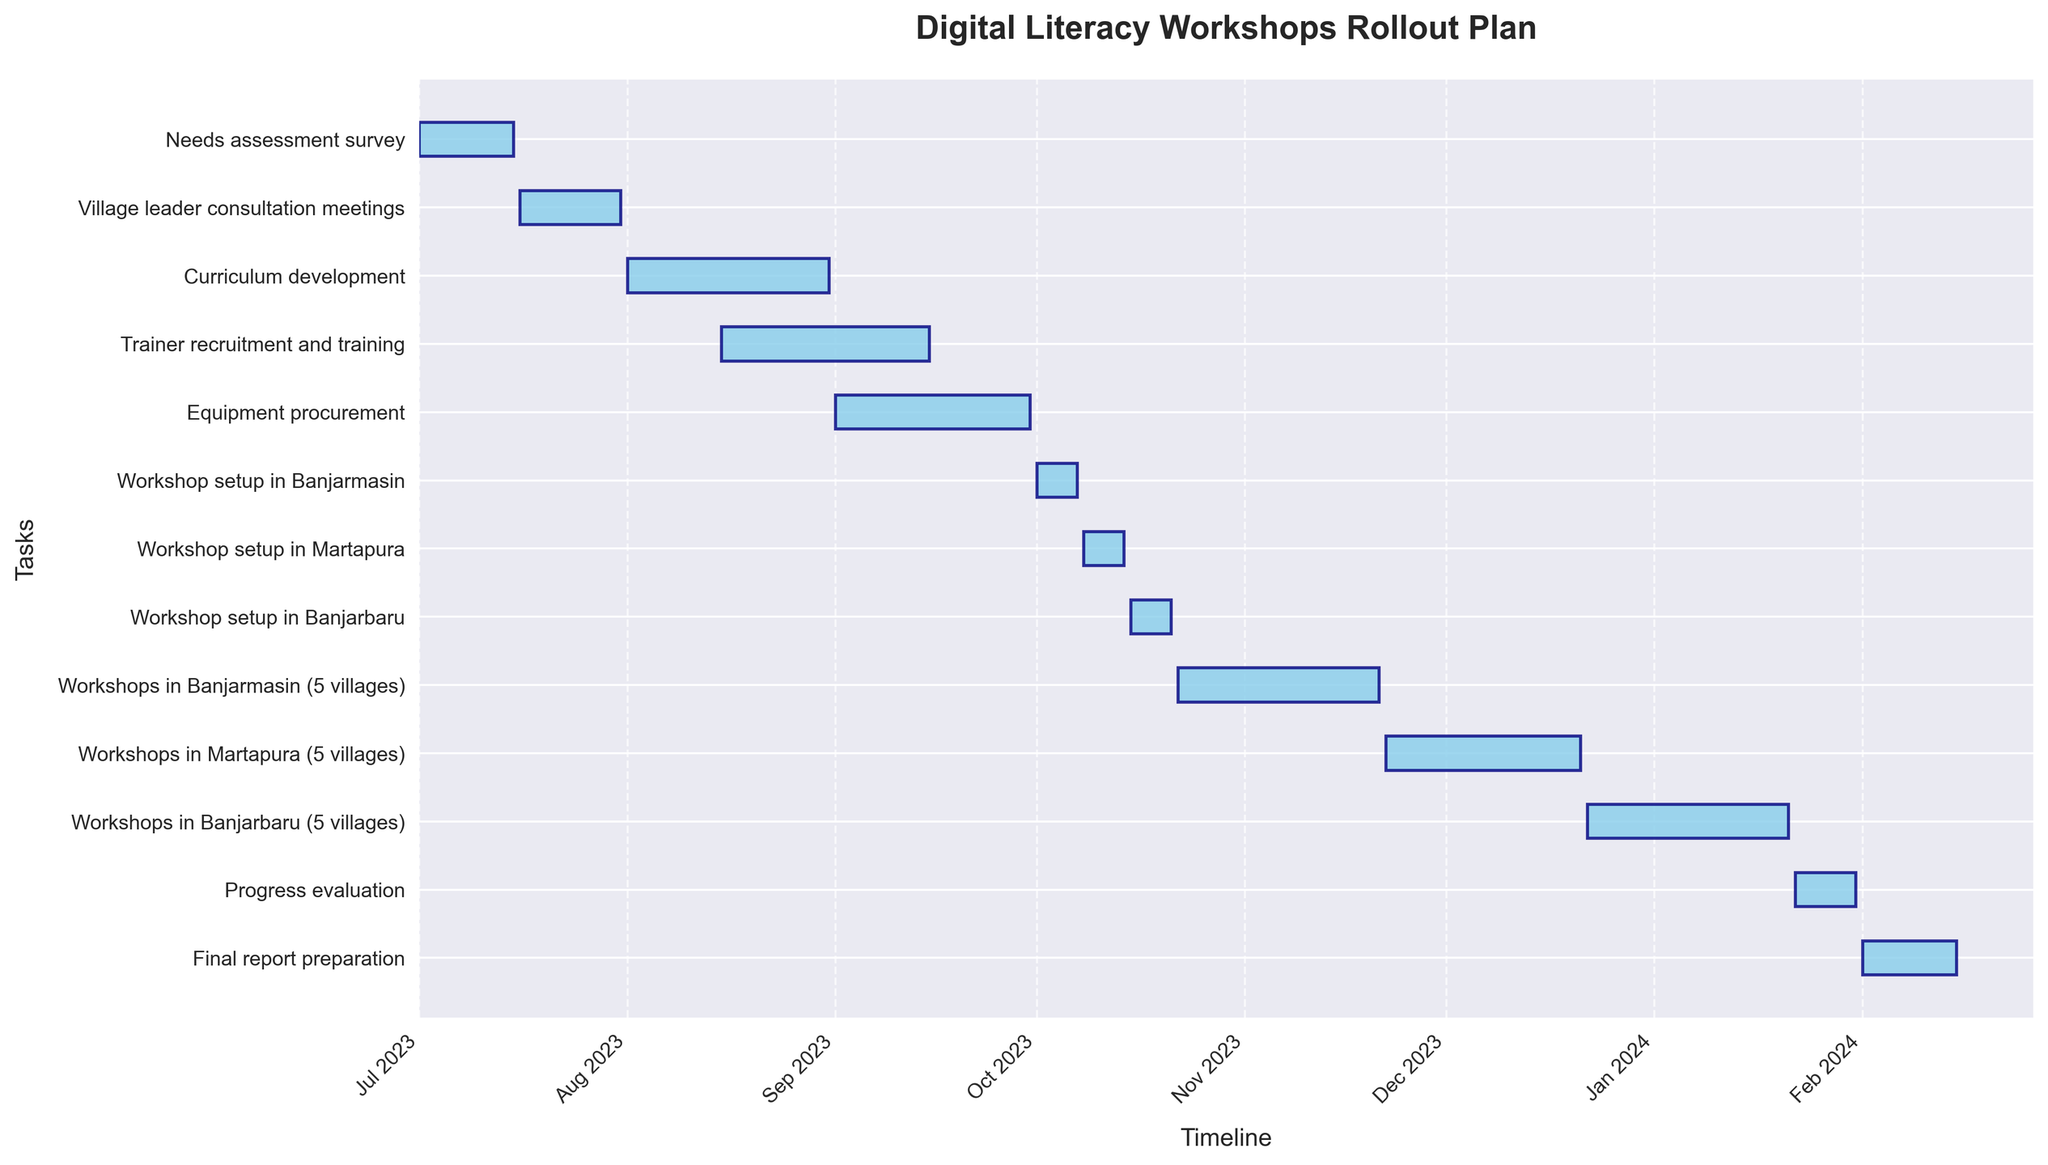What's the title of the chart? The title of the chart is displayed at the top of the figure and usually provides a summary of the content.
Answer: Digital Literacy Workshops Rollout Plan How long is the Needs assessment survey scheduled to last? To find the duration, look at the start and end dates for the Needs assessment survey task. The task starts on July 1, 2023, and ends on July 15, 2023.
Answer: 15 days What task follows the Equipment procurement? The task order can be understood by following the timeline from left to right. After Equipment procurement (which ends on September 30, 2023), the next task is the Workshop setup in Banjarmasin starting on October 1, 2023.
Answer: Workshop setup in Banjarmasin How long does Curriculum development last compared to Trainer recruitment and training? Curriculum development lasts from August 1 to August 31, which is 31 days. Trainer recruitment and training lasts from August 15 to September 15, which is also 31 days. Both tasks have the same duration.
Answer: Equal duration (31 days each) How many days are the workshops scheduled to run in Martapura? According to the chart, the workshops in Martapura start on November 22, 2023, and end on December 21, 2023. Calculate the days between these dates. (End Date - Start Date) = (December 21 - November 22) = 30 days.
Answer: 30 days Which task will be ongoing on October 10, 2023? To answer this question, find the task that overlaps with or includes the date October 10, 2023. According to the figure, the Workshop setup in Martapura is scheduled from October 8 to October 14, 2023.
Answer: Workshop setup in Martapura What is the longest task in the chart? To find the longest task, compare the durations of all tasks. Workshops in Banjarbaru, which runs from December 22, 2023, to January 21, 2024, has the longest duration of 31 days.
Answer: Workshops in Banjarbaru How many tasks are there before the workshops start in Banjarmasin? Count the number of tasks listed before "Workshops in Banjarmasin". These are Needs assessment survey, Village leader consultation meetings, Curriculum development, Trainer recruitment and training, Equipment procurement, and Workshop setup in Banjarmasin. There are six tasks before that.
Answer: 6 tasks How many months does the entire rollout plan cover? To calculate the total duration covered by the rollout plan, consider the start of the first task (July 1, 2023) and the end of the last task (February 15, 2024). The duration spans from July 2023 to February 2024, which is a total of 8 months.
Answer: 8 months Which village setup task has the highest overlap with Trainer recruitment and training? Trainer recruitment and training runs from August 15 to September 15. The only overlap observed is with Workshop setup in Banjarmasin, which starts on October 1. Thus, the overlap of tasks directly doesn't occur, query more logical overlaps without direct dates impacting task timeline.
Answer: None (direct overlap) 